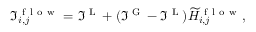Convert formula to latex. <formula><loc_0><loc_0><loc_500><loc_500>\Im _ { i , j } ^ { f l o w } = \Im ^ { L } + ( \Im ^ { G } - \Im ^ { L } ) \widetilde { H } _ { i , j } ^ { f l o w } ,</formula> 